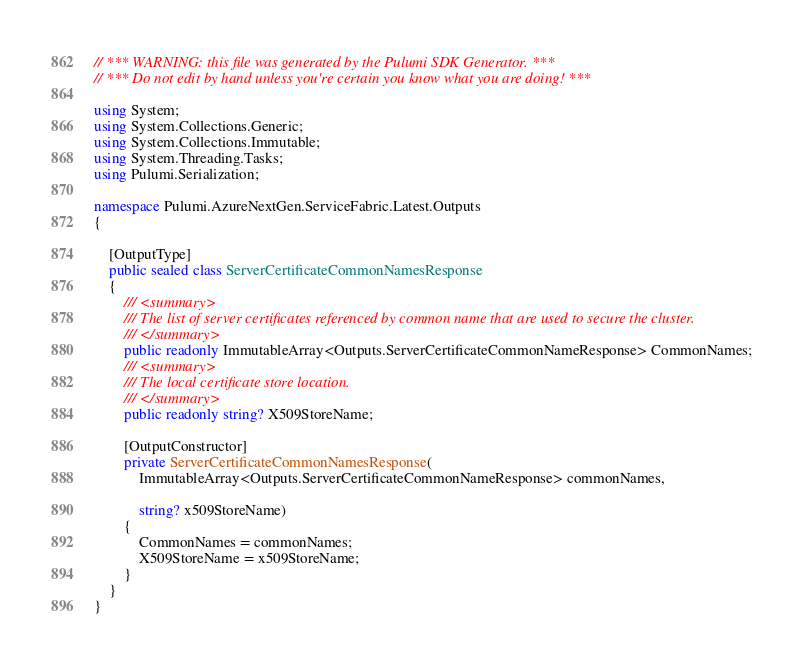Convert code to text. <code><loc_0><loc_0><loc_500><loc_500><_C#_>// *** WARNING: this file was generated by the Pulumi SDK Generator. ***
// *** Do not edit by hand unless you're certain you know what you are doing! ***

using System;
using System.Collections.Generic;
using System.Collections.Immutable;
using System.Threading.Tasks;
using Pulumi.Serialization;

namespace Pulumi.AzureNextGen.ServiceFabric.Latest.Outputs
{

    [OutputType]
    public sealed class ServerCertificateCommonNamesResponse
    {
        /// <summary>
        /// The list of server certificates referenced by common name that are used to secure the cluster.
        /// </summary>
        public readonly ImmutableArray<Outputs.ServerCertificateCommonNameResponse> CommonNames;
        /// <summary>
        /// The local certificate store location.
        /// </summary>
        public readonly string? X509StoreName;

        [OutputConstructor]
        private ServerCertificateCommonNamesResponse(
            ImmutableArray<Outputs.ServerCertificateCommonNameResponse> commonNames,

            string? x509StoreName)
        {
            CommonNames = commonNames;
            X509StoreName = x509StoreName;
        }
    }
}
</code> 